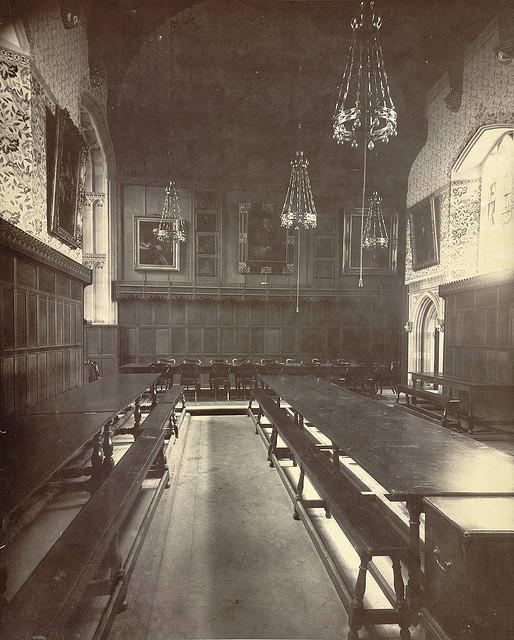How many dining tables are there?
Give a very brief answer. 3. How many benches are in the picture?
Give a very brief answer. 3. How many people are wearing hats?
Give a very brief answer. 0. 